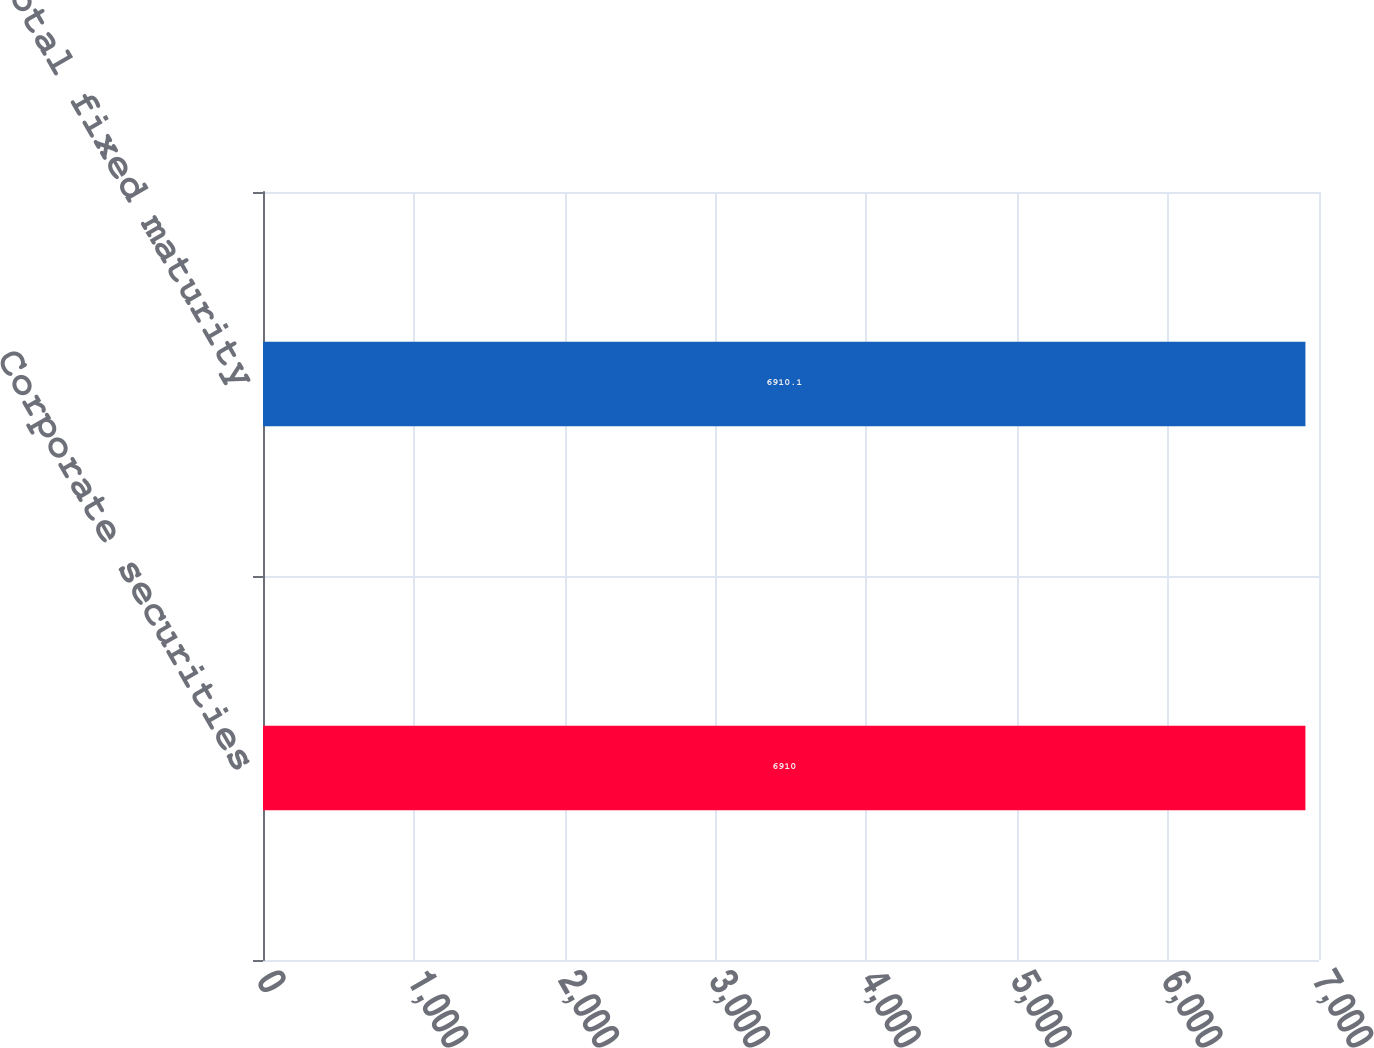<chart> <loc_0><loc_0><loc_500><loc_500><bar_chart><fcel>Corporate securities<fcel>Total fixed maturity<nl><fcel>6910<fcel>6910.1<nl></chart> 